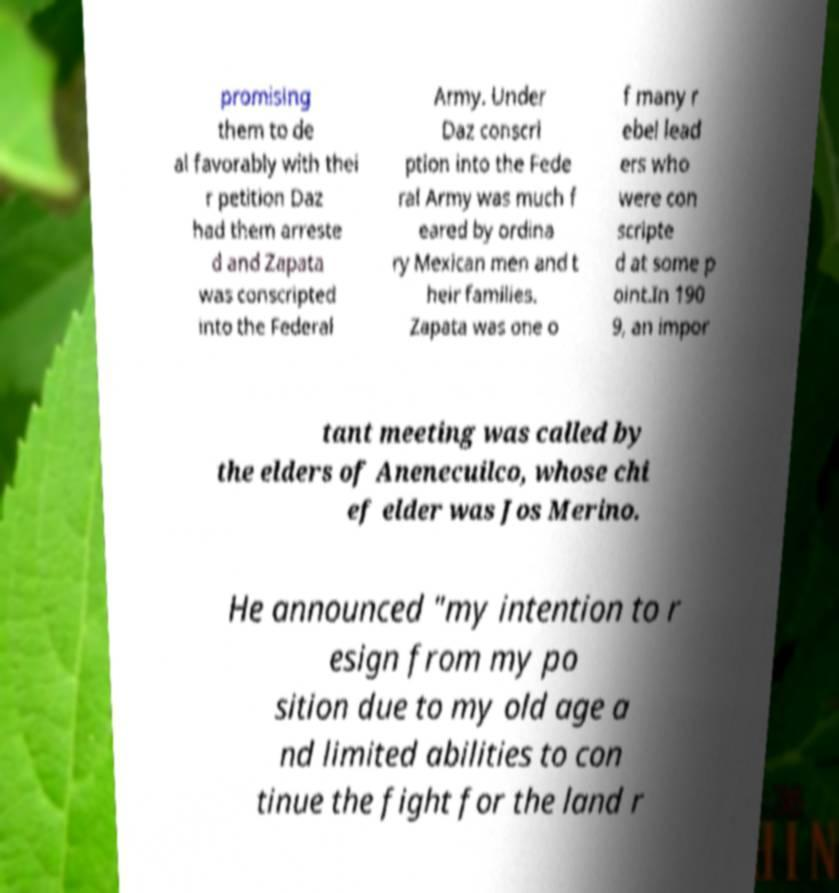I need the written content from this picture converted into text. Can you do that? promising them to de al favorably with thei r petition Daz had them arreste d and Zapata was conscripted into the Federal Army. Under Daz conscri ption into the Fede ral Army was much f eared by ordina ry Mexican men and t heir families. Zapata was one o f many r ebel lead ers who were con scripte d at some p oint.In 190 9, an impor tant meeting was called by the elders of Anenecuilco, whose chi ef elder was Jos Merino. He announced "my intention to r esign from my po sition due to my old age a nd limited abilities to con tinue the fight for the land r 